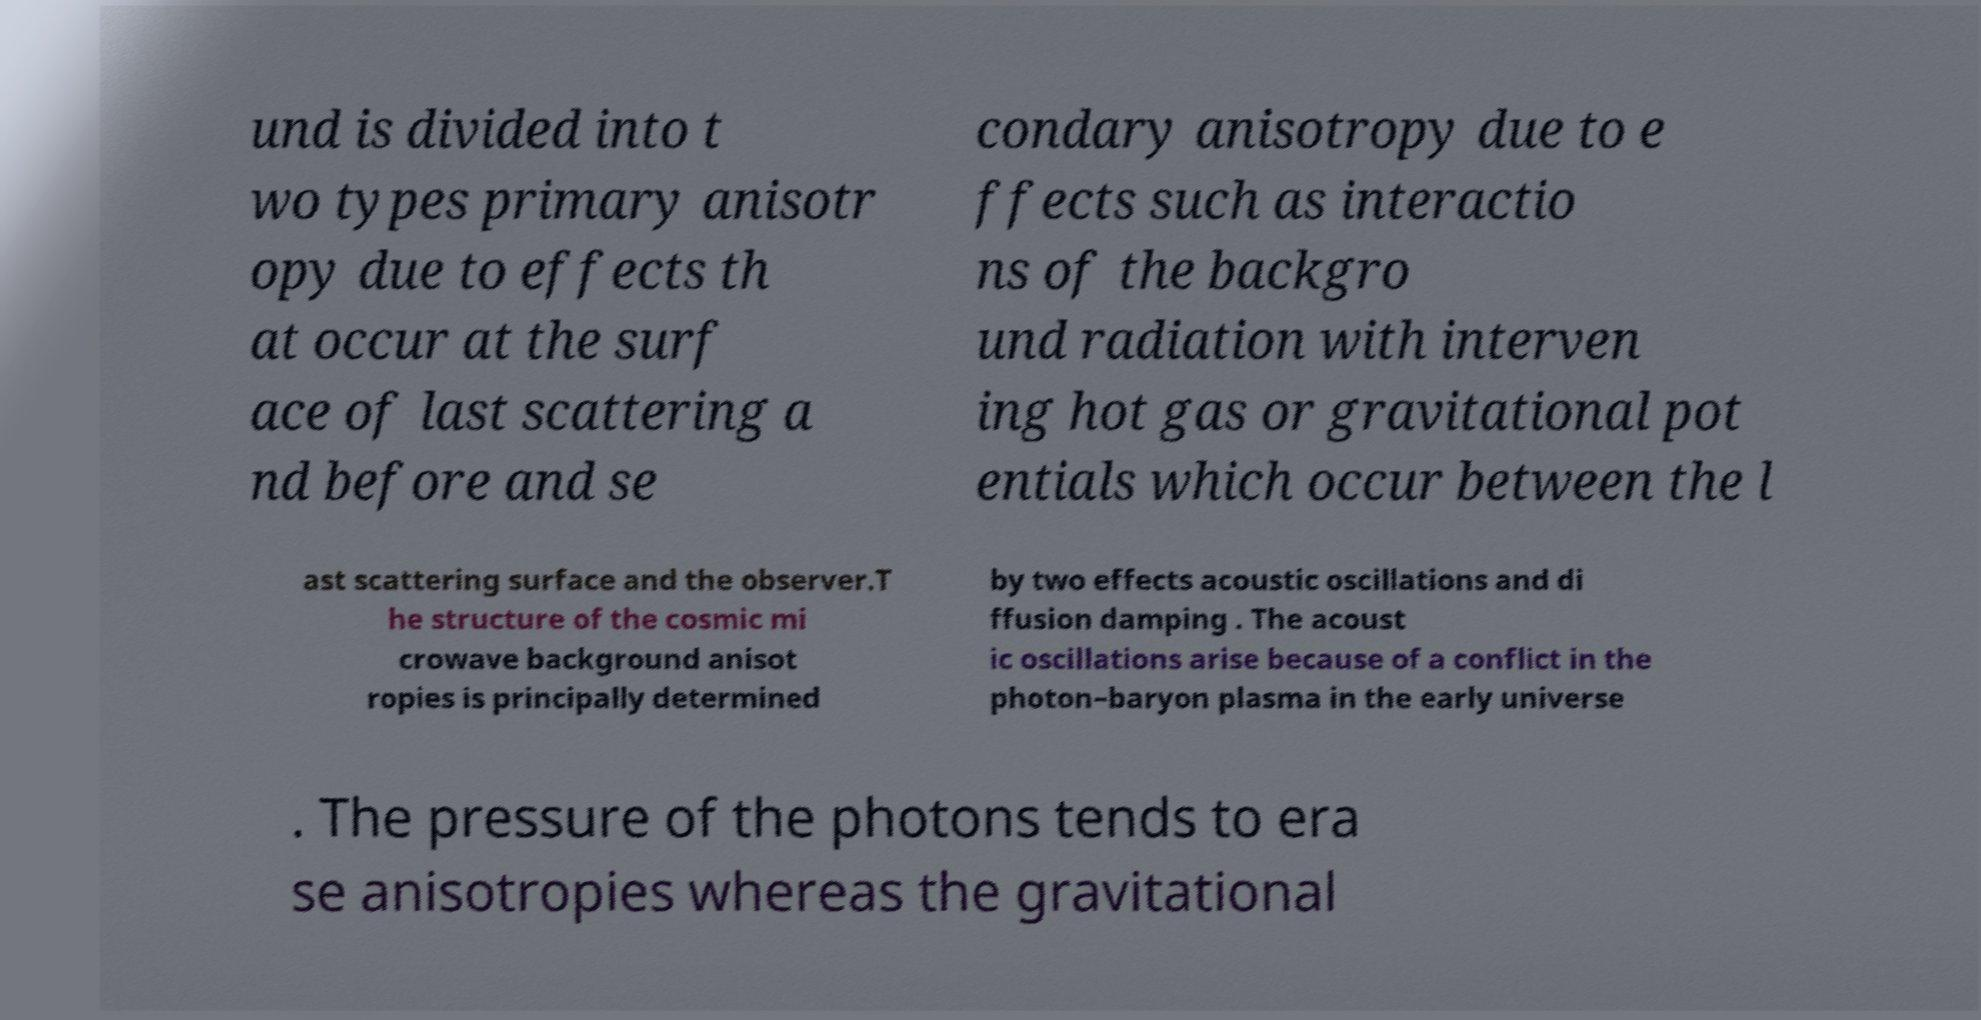Please identify and transcribe the text found in this image. und is divided into t wo types primary anisotr opy due to effects th at occur at the surf ace of last scattering a nd before and se condary anisotropy due to e ffects such as interactio ns of the backgro und radiation with interven ing hot gas or gravitational pot entials which occur between the l ast scattering surface and the observer.T he structure of the cosmic mi crowave background anisot ropies is principally determined by two effects acoustic oscillations and di ffusion damping . The acoust ic oscillations arise because of a conflict in the photon–baryon plasma in the early universe . The pressure of the photons tends to era se anisotropies whereas the gravitational 